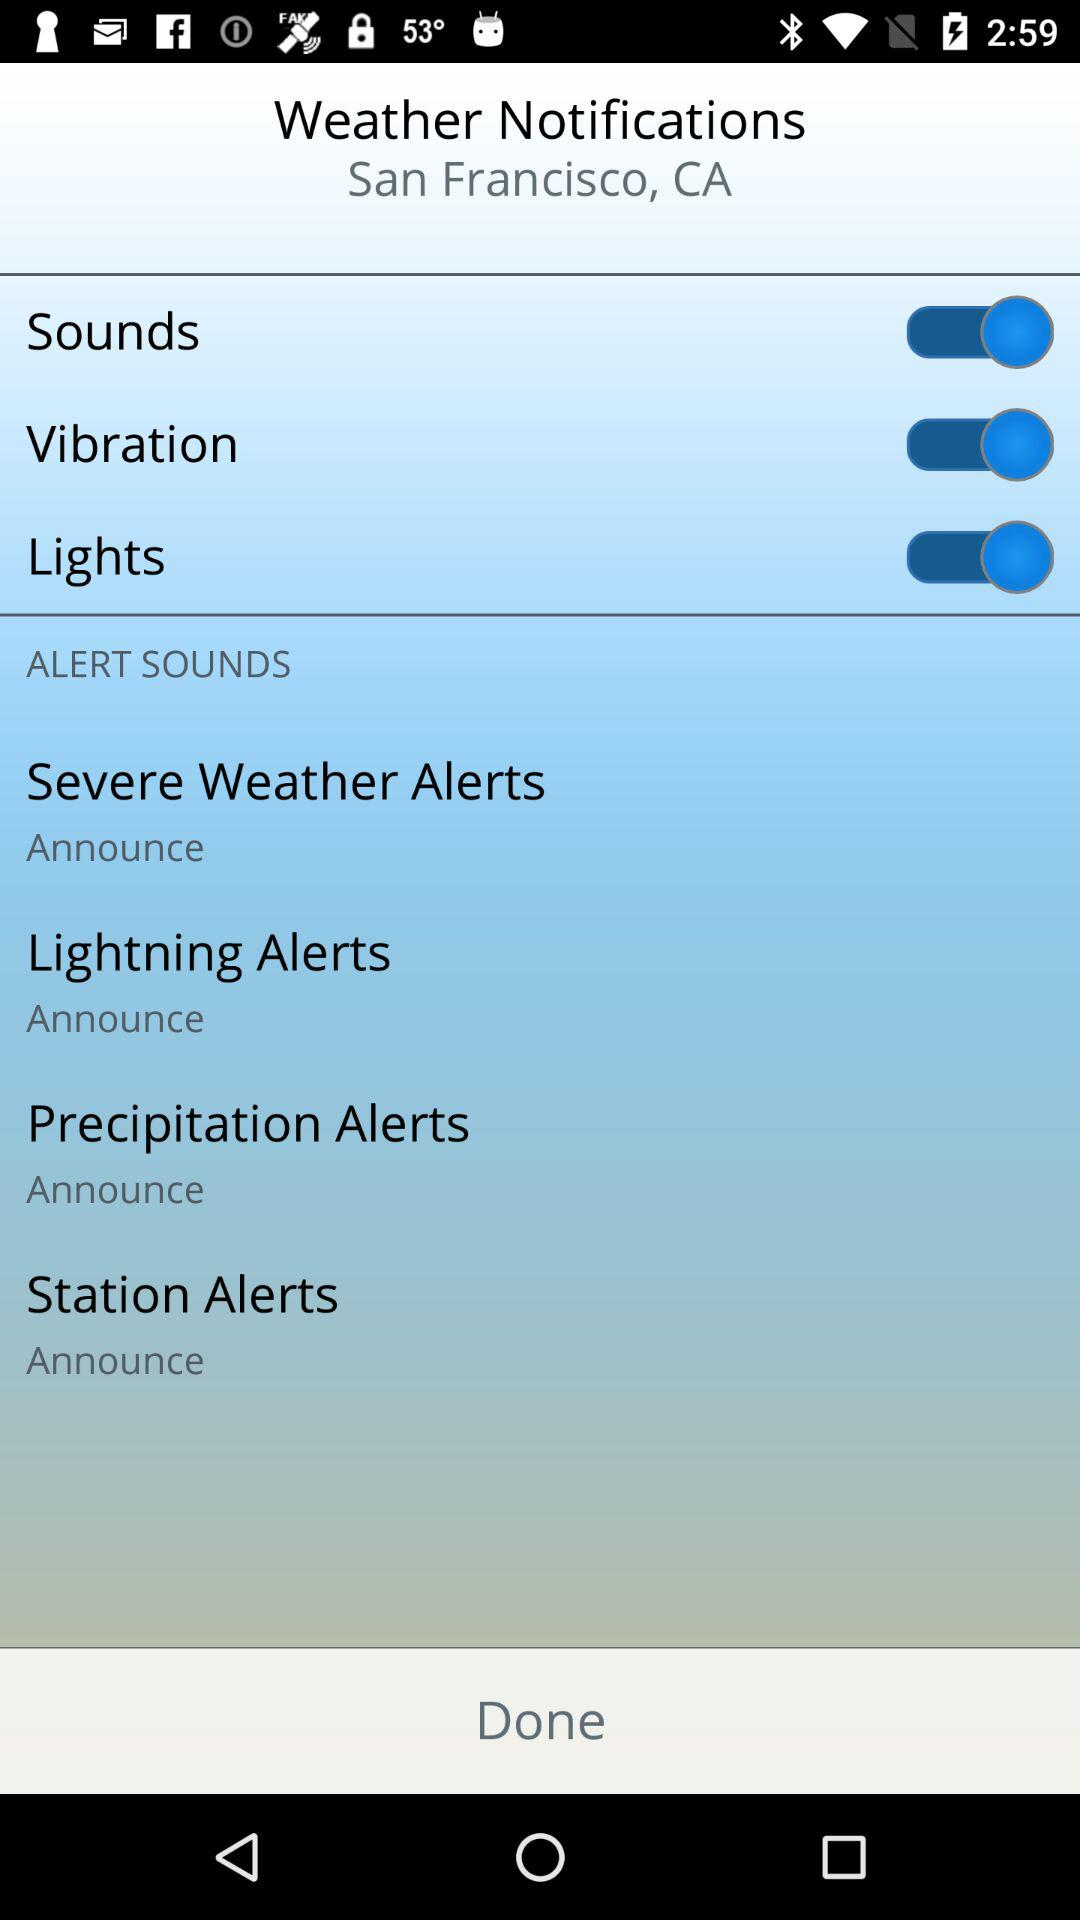How many alert sounds are there?
Answer the question using a single word or phrase. 4 